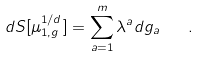<formula> <loc_0><loc_0><loc_500><loc_500>d S [ \mu _ { 1 , g } ^ { 1 / d } ] = \sum _ { a = 1 } ^ { m } \lambda ^ { a } d g _ { a } \quad .</formula> 